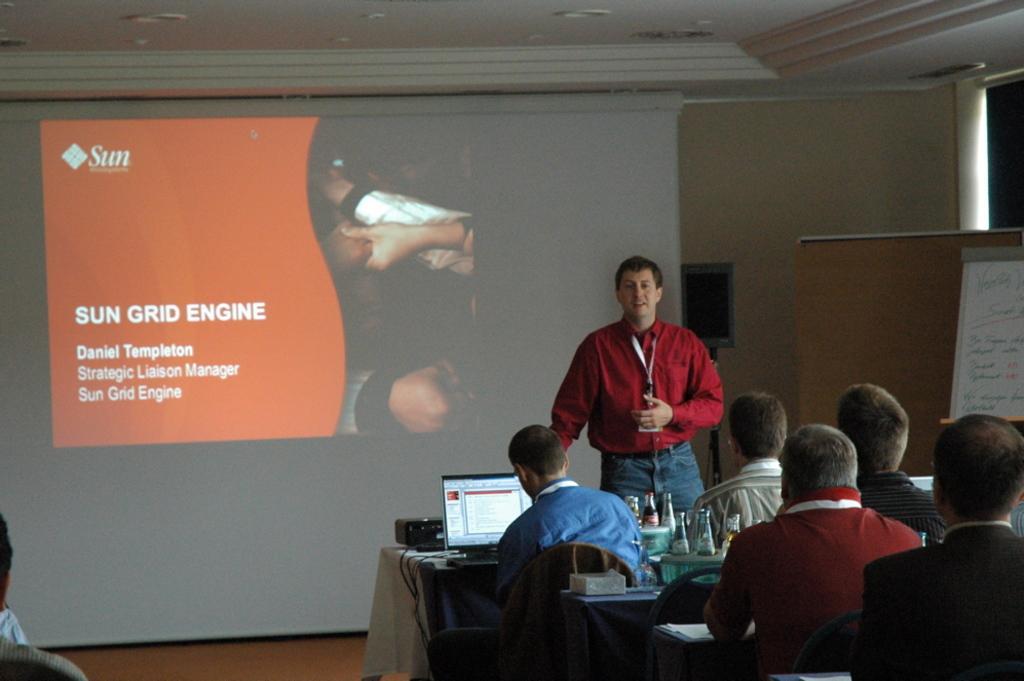Describe this image in one or two sentences. In this image there is a group are sitting on the chairs as we can see in the bottom right corner of this image. There is a laptop in the middle of this image. There is one person standing on the right side of this image. There is a screen as we can see in the middle of this image and there is a board on the right side of this image. There is one person sitting in the bottom left corner of this image. 